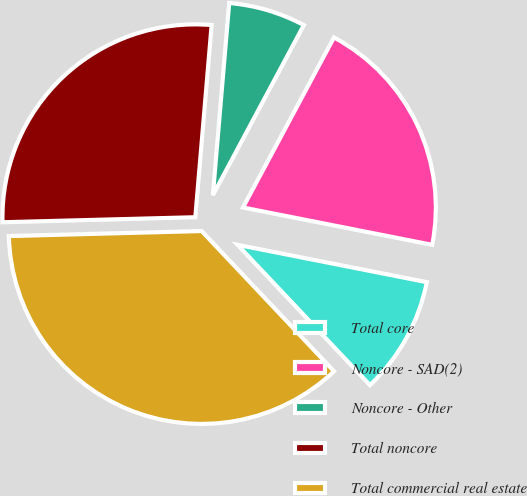Convert chart. <chart><loc_0><loc_0><loc_500><loc_500><pie_chart><fcel>Total core<fcel>Noncore - SAD(2)<fcel>Noncore - Other<fcel>Total noncore<fcel>Total commercial real estate<nl><fcel>9.86%<fcel>20.28%<fcel>6.47%<fcel>26.76%<fcel>36.62%<nl></chart> 